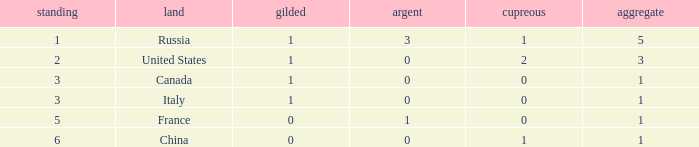Name the total number of golds when total is 1 and silver is 1 1.0. 